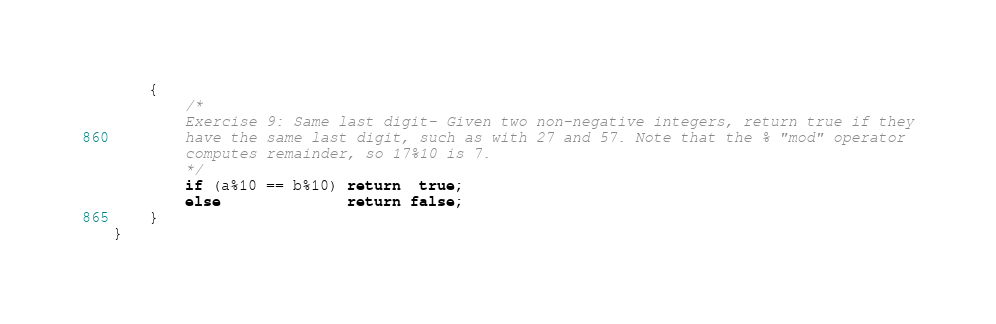<code> <loc_0><loc_0><loc_500><loc_500><_Java_>	{
		/*
		Exercise 9: Same last digit- Given two non-negative integers, return true if they
		have the same last digit, such as with 27 and 57. Note that the % "mod" operator
		computes remainder, so 17%10 is 7.
		*/
		if (a%10 == b%10) return  true;
		else              return false;
	}
}
</code> 